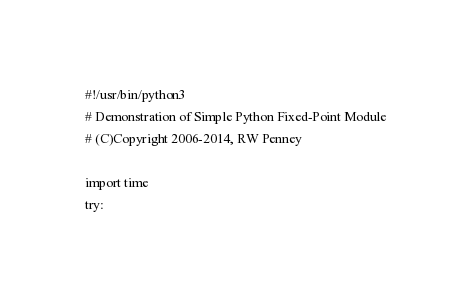<code> <loc_0><loc_0><loc_500><loc_500><_Python_>#!/usr/bin/python3
# Demonstration of Simple Python Fixed-Point Module
# (C)Copyright 2006-2014, RW Penney

import time
try:</code> 